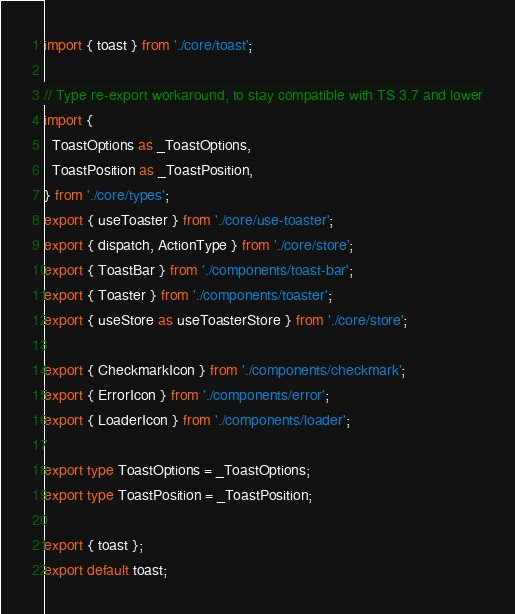<code> <loc_0><loc_0><loc_500><loc_500><_TypeScript_>import { toast } from './core/toast';

// Type re-export workaround, to stay compatible with TS 3.7 and lower
import {
  ToastOptions as _ToastOptions,
  ToastPosition as _ToastPosition,
} from './core/types';
export { useToaster } from './core/use-toaster';
export { dispatch, ActionType } from './core/store';
export { ToastBar } from './components/toast-bar';
export { Toaster } from './components/toaster';
export { useStore as useToasterStore } from './core/store';

export { CheckmarkIcon } from './components/checkmark';
export { ErrorIcon } from './components/error';
export { LoaderIcon } from './components/loader';

export type ToastOptions = _ToastOptions;
export type ToastPosition = _ToastPosition;

export { toast };
export default toast;
</code> 